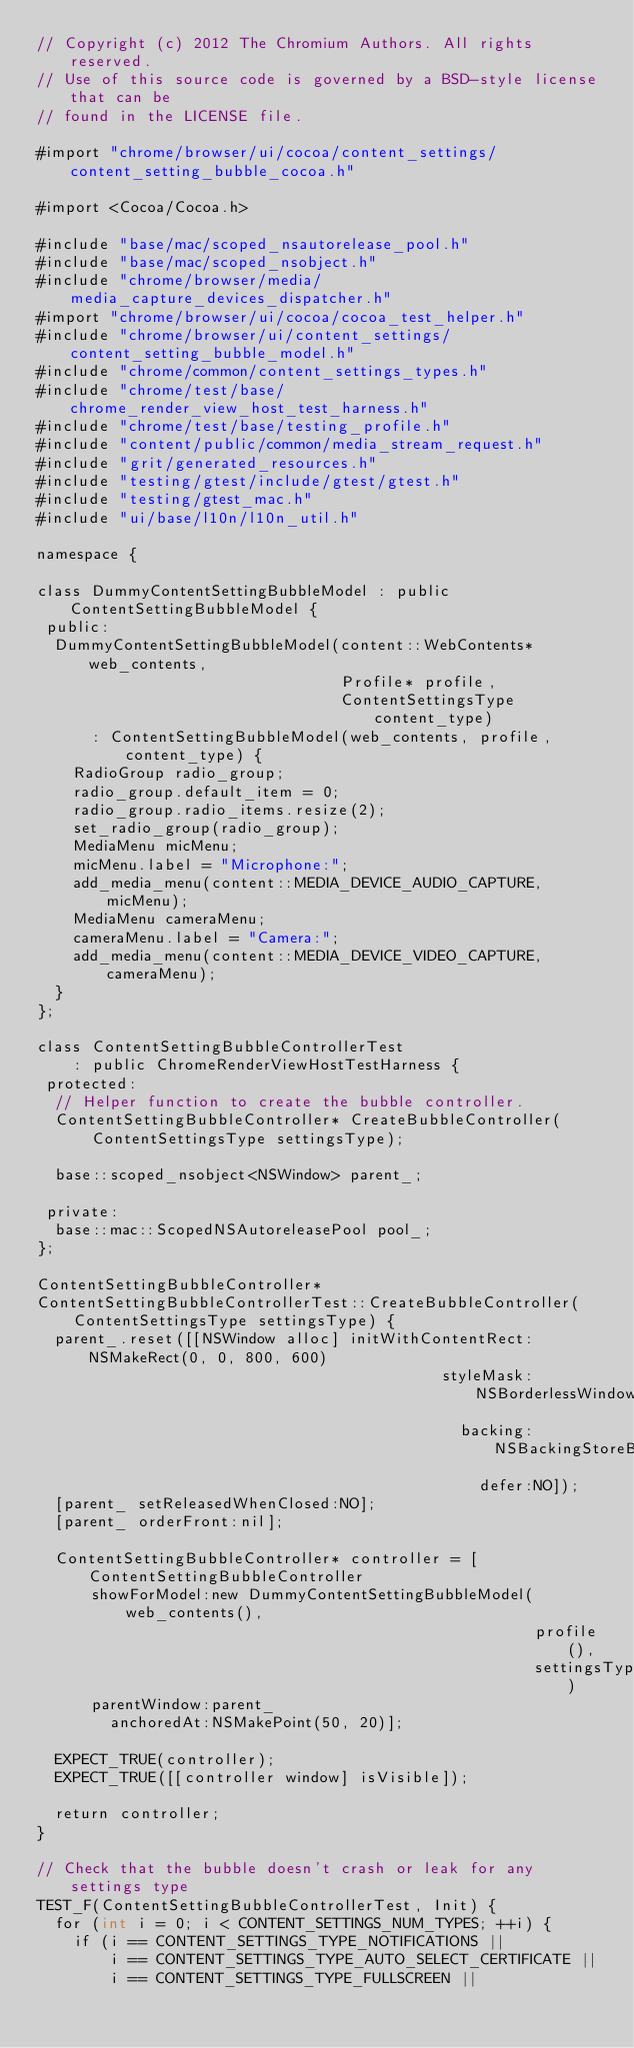Convert code to text. <code><loc_0><loc_0><loc_500><loc_500><_ObjectiveC_>// Copyright (c) 2012 The Chromium Authors. All rights reserved.
// Use of this source code is governed by a BSD-style license that can be
// found in the LICENSE file.

#import "chrome/browser/ui/cocoa/content_settings/content_setting_bubble_cocoa.h"

#import <Cocoa/Cocoa.h>

#include "base/mac/scoped_nsautorelease_pool.h"
#include "base/mac/scoped_nsobject.h"
#include "chrome/browser/media/media_capture_devices_dispatcher.h"
#import "chrome/browser/ui/cocoa/cocoa_test_helper.h"
#include "chrome/browser/ui/content_settings/content_setting_bubble_model.h"
#include "chrome/common/content_settings_types.h"
#include "chrome/test/base/chrome_render_view_host_test_harness.h"
#include "chrome/test/base/testing_profile.h"
#include "content/public/common/media_stream_request.h"
#include "grit/generated_resources.h"
#include "testing/gtest/include/gtest/gtest.h"
#include "testing/gtest_mac.h"
#include "ui/base/l10n/l10n_util.h"

namespace {

class DummyContentSettingBubbleModel : public ContentSettingBubbleModel {
 public:
  DummyContentSettingBubbleModel(content::WebContents* web_contents,
                                 Profile* profile,
                                 ContentSettingsType content_type)
      : ContentSettingBubbleModel(web_contents, profile, content_type) {
    RadioGroup radio_group;
    radio_group.default_item = 0;
    radio_group.radio_items.resize(2);
    set_radio_group(radio_group);
    MediaMenu micMenu;
    micMenu.label = "Microphone:";
    add_media_menu(content::MEDIA_DEVICE_AUDIO_CAPTURE, micMenu);
    MediaMenu cameraMenu;
    cameraMenu.label = "Camera:";
    add_media_menu(content::MEDIA_DEVICE_VIDEO_CAPTURE, cameraMenu);
  }
};

class ContentSettingBubbleControllerTest
    : public ChromeRenderViewHostTestHarness {
 protected:
  // Helper function to create the bubble controller.
  ContentSettingBubbleController* CreateBubbleController(
      ContentSettingsType settingsType);

  base::scoped_nsobject<NSWindow> parent_;

 private:
  base::mac::ScopedNSAutoreleasePool pool_;
};

ContentSettingBubbleController*
ContentSettingBubbleControllerTest::CreateBubbleController(
    ContentSettingsType settingsType) {
  parent_.reset([[NSWindow alloc] initWithContentRect:NSMakeRect(0, 0, 800, 600)
                                            styleMask:NSBorderlessWindowMask
                                              backing:NSBackingStoreBuffered
                                                defer:NO]);
  [parent_ setReleasedWhenClosed:NO];
  [parent_ orderFront:nil];

  ContentSettingBubbleController* controller = [ContentSettingBubbleController
      showForModel:new DummyContentSettingBubbleModel(web_contents(),
                                                      profile(),
                                                      settingsType)
      parentWindow:parent_
        anchoredAt:NSMakePoint(50, 20)];

  EXPECT_TRUE(controller);
  EXPECT_TRUE([[controller window] isVisible]);

  return controller;
}

// Check that the bubble doesn't crash or leak for any settings type
TEST_F(ContentSettingBubbleControllerTest, Init) {
  for (int i = 0; i < CONTENT_SETTINGS_NUM_TYPES; ++i) {
    if (i == CONTENT_SETTINGS_TYPE_NOTIFICATIONS ||
        i == CONTENT_SETTINGS_TYPE_AUTO_SELECT_CERTIFICATE ||
        i == CONTENT_SETTINGS_TYPE_FULLSCREEN ||</code> 